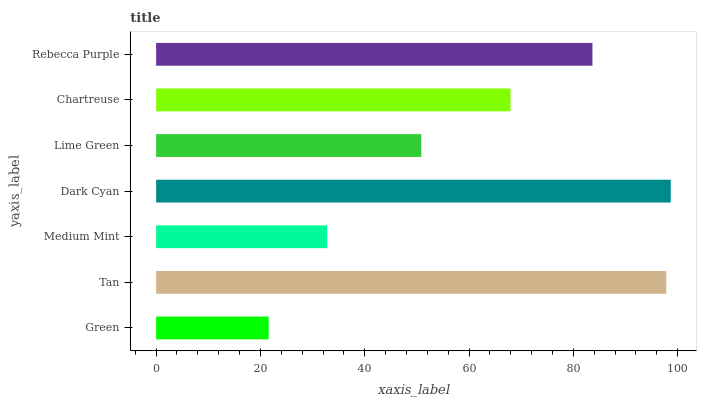Is Green the minimum?
Answer yes or no. Yes. Is Dark Cyan the maximum?
Answer yes or no. Yes. Is Tan the minimum?
Answer yes or no. No. Is Tan the maximum?
Answer yes or no. No. Is Tan greater than Green?
Answer yes or no. Yes. Is Green less than Tan?
Answer yes or no. Yes. Is Green greater than Tan?
Answer yes or no. No. Is Tan less than Green?
Answer yes or no. No. Is Chartreuse the high median?
Answer yes or no. Yes. Is Chartreuse the low median?
Answer yes or no. Yes. Is Lime Green the high median?
Answer yes or no. No. Is Green the low median?
Answer yes or no. No. 